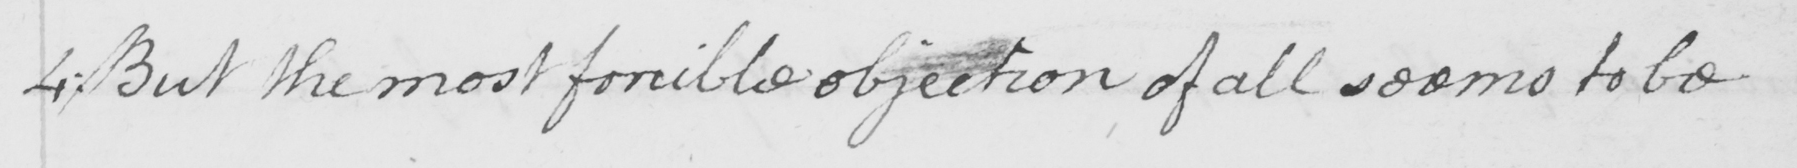Can you read and transcribe this handwriting? 4 :  But the most forcible objection of all seems to be 